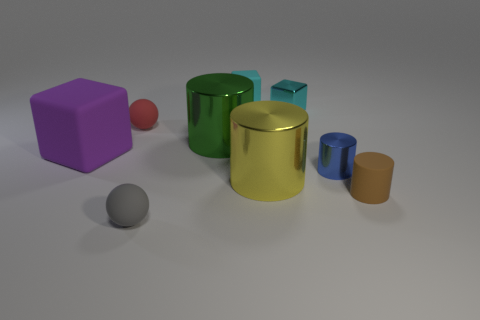Subtract 1 cylinders. How many cylinders are left? 3 Subtract all tiny blue cylinders. How many cylinders are left? 3 Subtract all cyan cylinders. Subtract all cyan spheres. How many cylinders are left? 4 Add 1 big matte cylinders. How many objects exist? 10 Subtract all blocks. How many objects are left? 6 Subtract all small cyan rubber things. Subtract all small red rubber cubes. How many objects are left? 8 Add 7 big matte objects. How many big matte objects are left? 8 Add 9 tiny rubber cubes. How many tiny rubber cubes exist? 10 Subtract 1 blue cylinders. How many objects are left? 8 